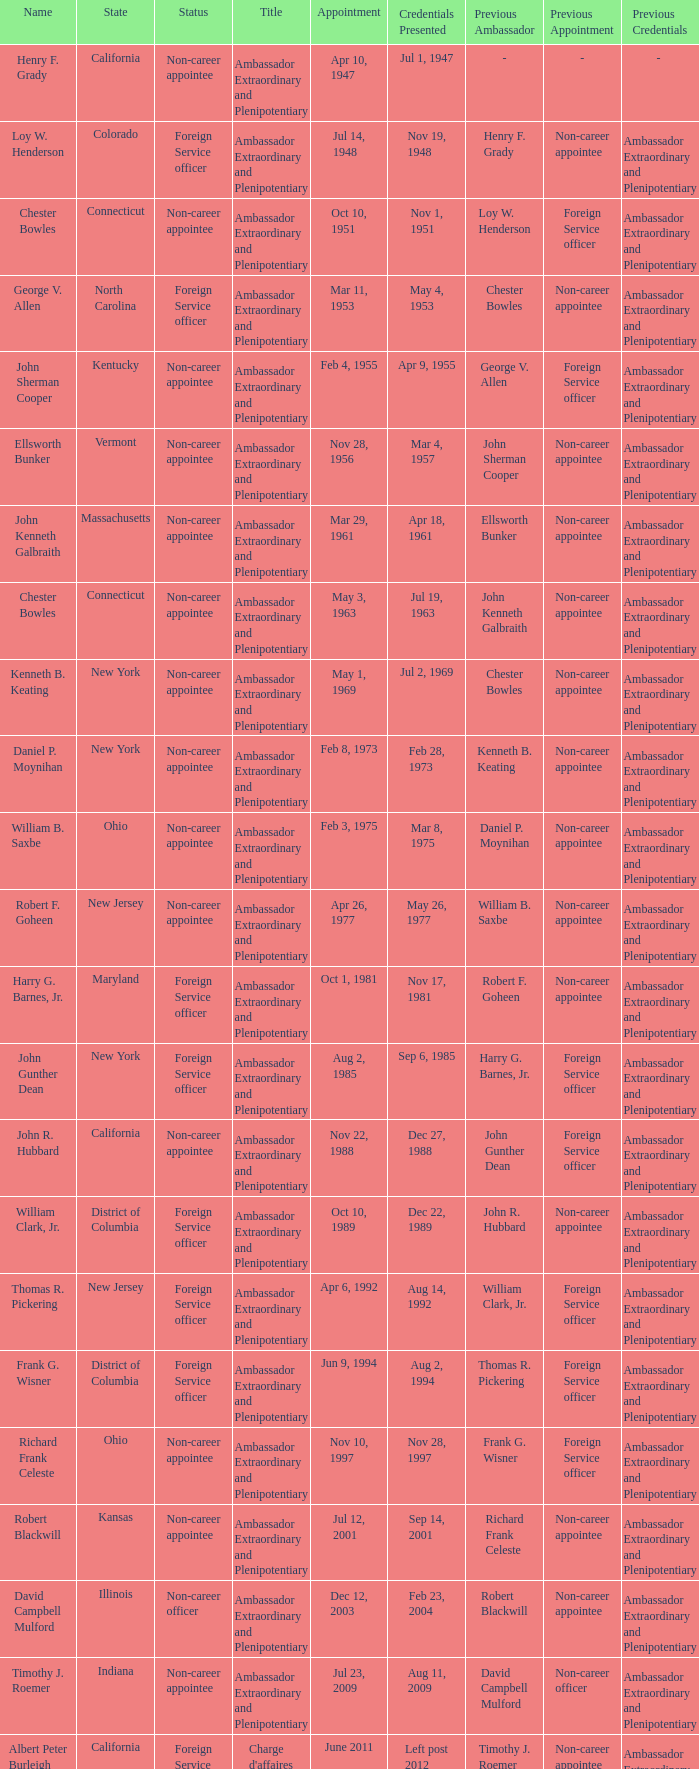What is the title for david campbell mulford? Ambassador Extraordinary and Plenipotentiary. 